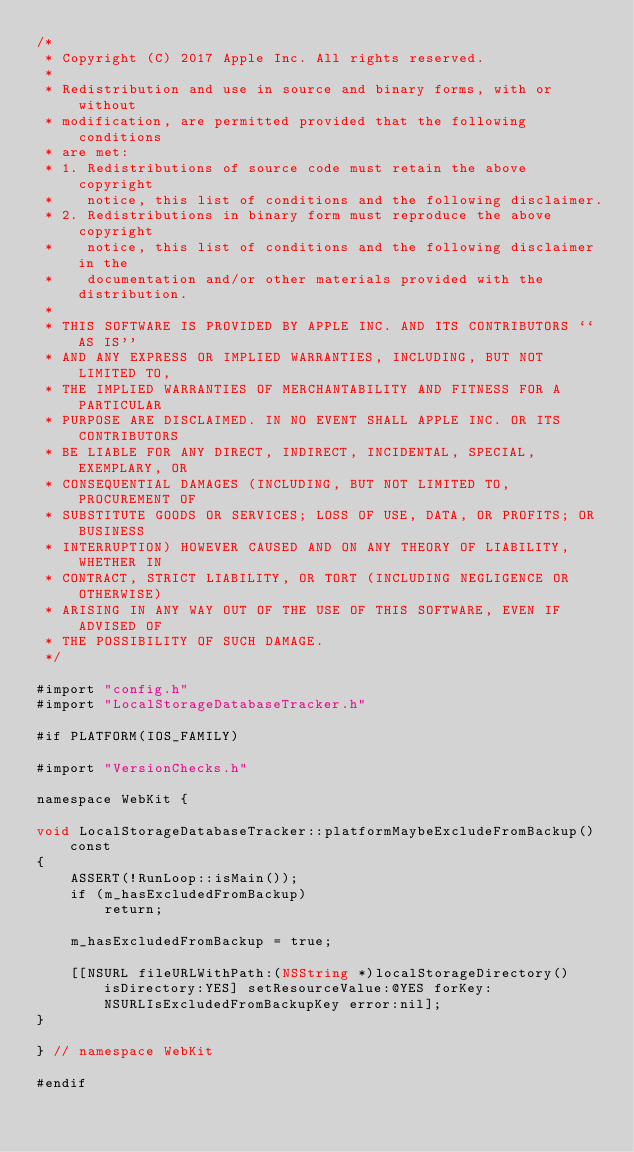<code> <loc_0><loc_0><loc_500><loc_500><_ObjectiveC_>/*
 * Copyright (C) 2017 Apple Inc. All rights reserved.
 *
 * Redistribution and use in source and binary forms, with or without
 * modification, are permitted provided that the following conditions
 * are met:
 * 1. Redistributions of source code must retain the above copyright
 *    notice, this list of conditions and the following disclaimer.
 * 2. Redistributions in binary form must reproduce the above copyright
 *    notice, this list of conditions and the following disclaimer in the
 *    documentation and/or other materials provided with the distribution.
 *
 * THIS SOFTWARE IS PROVIDED BY APPLE INC. AND ITS CONTRIBUTORS ``AS IS''
 * AND ANY EXPRESS OR IMPLIED WARRANTIES, INCLUDING, BUT NOT LIMITED TO,
 * THE IMPLIED WARRANTIES OF MERCHANTABILITY AND FITNESS FOR A PARTICULAR
 * PURPOSE ARE DISCLAIMED. IN NO EVENT SHALL APPLE INC. OR ITS CONTRIBUTORS
 * BE LIABLE FOR ANY DIRECT, INDIRECT, INCIDENTAL, SPECIAL, EXEMPLARY, OR
 * CONSEQUENTIAL DAMAGES (INCLUDING, BUT NOT LIMITED TO, PROCUREMENT OF
 * SUBSTITUTE GOODS OR SERVICES; LOSS OF USE, DATA, OR PROFITS; OR BUSINESS
 * INTERRUPTION) HOWEVER CAUSED AND ON ANY THEORY OF LIABILITY, WHETHER IN
 * CONTRACT, STRICT LIABILITY, OR TORT (INCLUDING NEGLIGENCE OR OTHERWISE)
 * ARISING IN ANY WAY OUT OF THE USE OF THIS SOFTWARE, EVEN IF ADVISED OF
 * THE POSSIBILITY OF SUCH DAMAGE.
 */

#import "config.h"
#import "LocalStorageDatabaseTracker.h"

#if PLATFORM(IOS_FAMILY)

#import "VersionChecks.h"

namespace WebKit {

void LocalStorageDatabaseTracker::platformMaybeExcludeFromBackup() const
{
    ASSERT(!RunLoop::isMain());
    if (m_hasExcludedFromBackup)
        return;

    m_hasExcludedFromBackup = true;

    [[NSURL fileURLWithPath:(NSString *)localStorageDirectory() isDirectory:YES] setResourceValue:@YES forKey:NSURLIsExcludedFromBackupKey error:nil];
}

} // namespace WebKit

#endif
</code> 